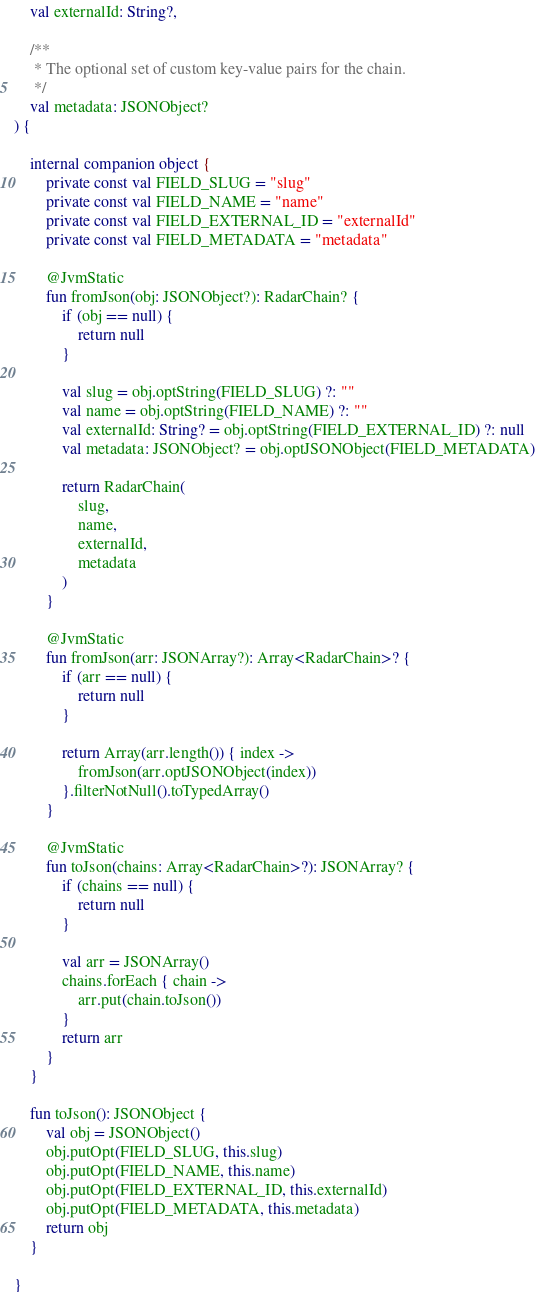<code> <loc_0><loc_0><loc_500><loc_500><_Kotlin_>    val externalId: String?,

    /**
     * The optional set of custom key-value pairs for the chain.
     */
    val metadata: JSONObject?
) {

    internal companion object {
        private const val FIELD_SLUG = "slug"
        private const val FIELD_NAME = "name"
        private const val FIELD_EXTERNAL_ID = "externalId"
        private const val FIELD_METADATA = "metadata"

        @JvmStatic
        fun fromJson(obj: JSONObject?): RadarChain? {
            if (obj == null) {
                return null
            }

            val slug = obj.optString(FIELD_SLUG) ?: ""
            val name = obj.optString(FIELD_NAME) ?: ""
            val externalId: String? = obj.optString(FIELD_EXTERNAL_ID) ?: null
            val metadata: JSONObject? = obj.optJSONObject(FIELD_METADATA)

            return RadarChain(
                slug,
                name,
                externalId,
                metadata
            )
        }

        @JvmStatic
        fun fromJson(arr: JSONArray?): Array<RadarChain>? {
            if (arr == null) {
                return null
            }

            return Array(arr.length()) { index ->
                fromJson(arr.optJSONObject(index))
            }.filterNotNull().toTypedArray()
        }

        @JvmStatic
        fun toJson(chains: Array<RadarChain>?): JSONArray? {
            if (chains == null) {
                return null
            }

            val arr = JSONArray()
            chains.forEach { chain ->
                arr.put(chain.toJson())
            }
            return arr
        }
    }

    fun toJson(): JSONObject {
        val obj = JSONObject()
        obj.putOpt(FIELD_SLUG, this.slug)
        obj.putOpt(FIELD_NAME, this.name)
        obj.putOpt(FIELD_EXTERNAL_ID, this.externalId)
        obj.putOpt(FIELD_METADATA, this.metadata)
        return obj
    }

}</code> 